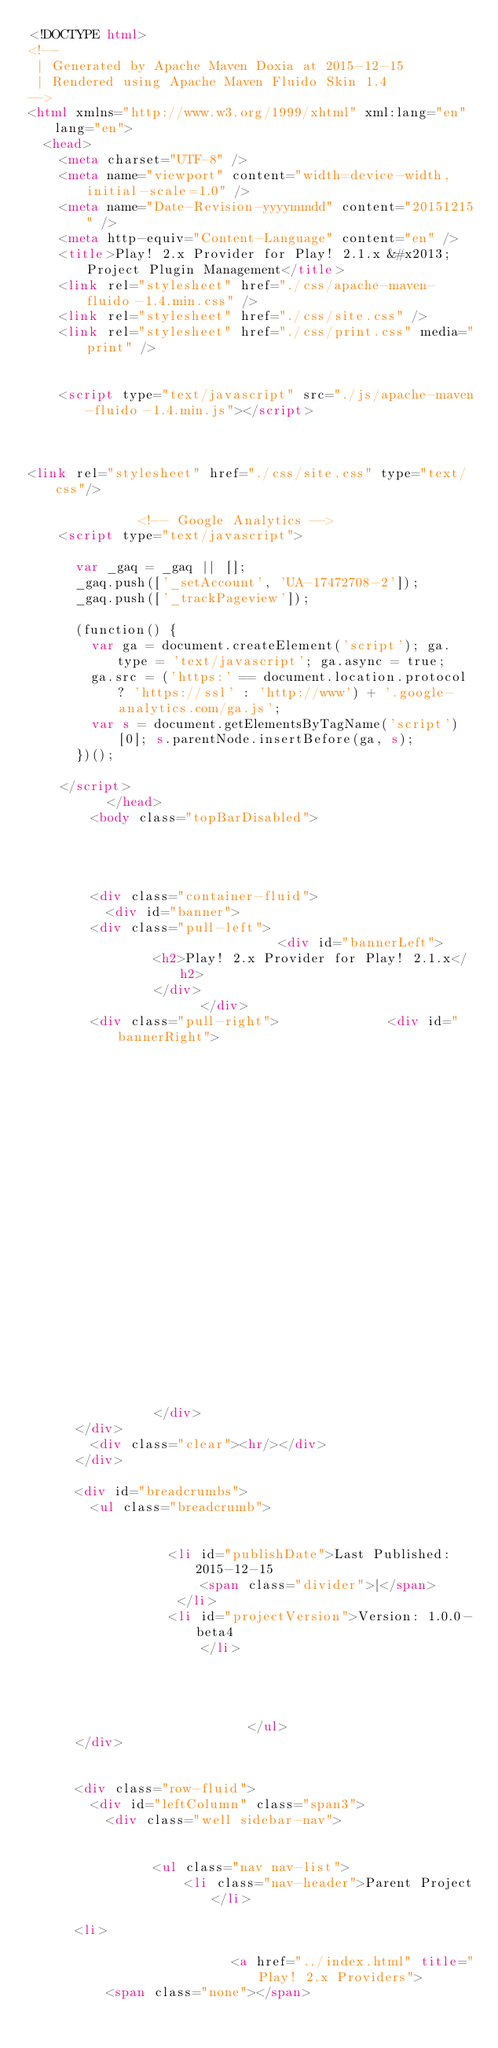<code> <loc_0><loc_0><loc_500><loc_500><_HTML_><!DOCTYPE html>
<!--
 | Generated by Apache Maven Doxia at 2015-12-15 
 | Rendered using Apache Maven Fluido Skin 1.4
-->
<html xmlns="http://www.w3.org/1999/xhtml" xml:lang="en" lang="en">
  <head>
    <meta charset="UTF-8" />
    <meta name="viewport" content="width=device-width, initial-scale=1.0" />
    <meta name="Date-Revision-yyyymmdd" content="20151215" />
    <meta http-equiv="Content-Language" content="en" />
    <title>Play! 2.x Provider for Play! 2.1.x &#x2013; Project Plugin Management</title>
    <link rel="stylesheet" href="./css/apache-maven-fluido-1.4.min.css" />
    <link rel="stylesheet" href="./css/site.css" />
    <link rel="stylesheet" href="./css/print.css" media="print" />

      
    <script type="text/javascript" src="./js/apache-maven-fluido-1.4.min.js"></script>

                          
        
<link rel="stylesheet" href="./css/site.css" type="text/css"/>
          
              <!-- Google Analytics -->
    <script type="text/javascript">

      var _gaq = _gaq || [];
      _gaq.push(['_setAccount', 'UA-17472708-2']);
      _gaq.push(['_trackPageview']);

      (function() {
        var ga = document.createElement('script'); ga.type = 'text/javascript'; ga.async = true;
        ga.src = ('https:' == document.location.protocol ? 'https://ssl' : 'http://www') + '.google-analytics.com/ga.js';
        var s = document.getElementsByTagName('script')[0]; s.parentNode.insertBefore(ga, s);
      })();

    </script>
          </head>
        <body class="topBarDisabled">
          
                
                    
    
        <div class="container-fluid">
          <div id="banner">
        <div class="pull-left">
                                <div id="bannerLeft">
                <h2>Play! 2.x Provider for Play! 2.1.x</h2>
                </div>
                      </div>
        <div class="pull-right">              <div id="bannerRight">
                                                                                                <img src="images/my-avatar-80.png"  alt="avatar"/>
                </div>
      </div>
        <div class="clear"><hr/></div>
      </div>

      <div id="breadcrumbs">
        <ul class="breadcrumb">
                
                    
                  <li id="publishDate">Last Published: 2015-12-15
                      <span class="divider">|</span>
                   </li>
                  <li id="projectVersion">Version: 1.0.0-beta4
                      </li>
                      
                
                    
      
                            </ul>
      </div>

                  
      <div class="row-fluid">
        <div id="leftColumn" class="span3">
          <div class="well sidebar-nav">
                
                    
                <ul class="nav nav-list">
                    <li class="nav-header">Parent Project</li>
                              
      <li>
  
                          <a href="../index.html" title="Play! 2.x Providers">
          <span class="none"></span></code> 